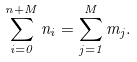Convert formula to latex. <formula><loc_0><loc_0><loc_500><loc_500>\sum _ { i = 0 } ^ { n + M } n _ { i } = \sum _ { j = 1 } ^ { M } m _ { j } .</formula> 